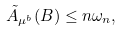Convert formula to latex. <formula><loc_0><loc_0><loc_500><loc_500>\tilde { A } _ { { \mu } ^ { b } } ( B ) \leq n \omega _ { n } ,</formula> 